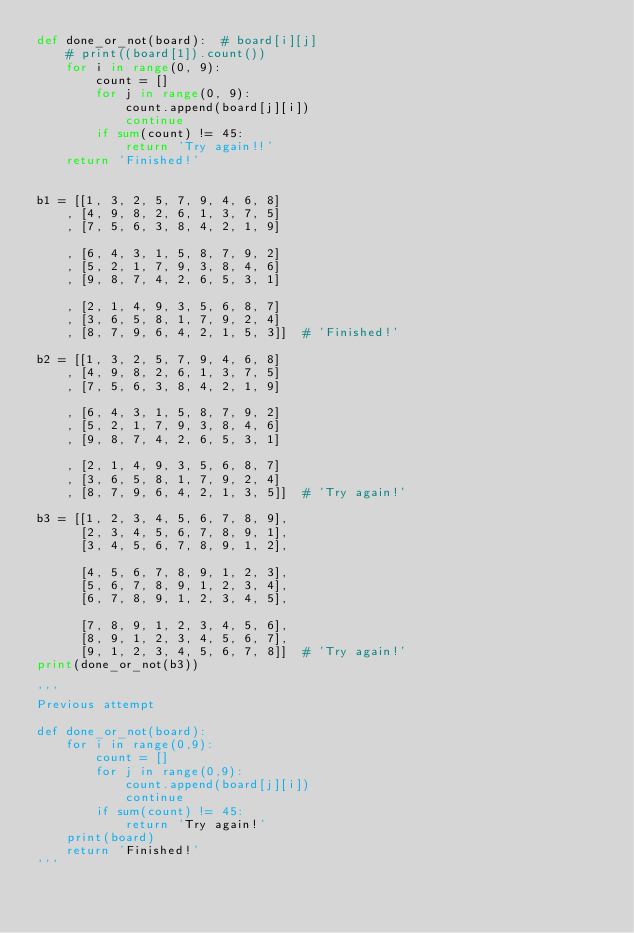Convert code to text. <code><loc_0><loc_0><loc_500><loc_500><_Python_>def done_or_not(board):  # board[i][j]
    # print((board[1]).count())
    for i in range(0, 9):
        count = []
        for j in range(0, 9):
            count.append(board[j][i])
            continue
        if sum(count) != 45:
            return 'Try again!!'
    return 'Finished!'


b1 = [[1, 3, 2, 5, 7, 9, 4, 6, 8]
    , [4, 9, 8, 2, 6, 1, 3, 7, 5]
    , [7, 5, 6, 3, 8, 4, 2, 1, 9]

    , [6, 4, 3, 1, 5, 8, 7, 9, 2]
    , [5, 2, 1, 7, 9, 3, 8, 4, 6]
    , [9, 8, 7, 4, 2, 6, 5, 3, 1]

    , [2, 1, 4, 9, 3, 5, 6, 8, 7]
    , [3, 6, 5, 8, 1, 7, 9, 2, 4]
    , [8, 7, 9, 6, 4, 2, 1, 5, 3]]  # 'Finished!'

b2 = [[1, 3, 2, 5, 7, 9, 4, 6, 8]
    , [4, 9, 8, 2, 6, 1, 3, 7, 5]
    , [7, 5, 6, 3, 8, 4, 2, 1, 9]

    , [6, 4, 3, 1, 5, 8, 7, 9, 2]
    , [5, 2, 1, 7, 9, 3, 8, 4, 6]
    , [9, 8, 7, 4, 2, 6, 5, 3, 1]

    , [2, 1, 4, 9, 3, 5, 6, 8, 7]
    , [3, 6, 5, 8, 1, 7, 9, 2, 4]
    , [8, 7, 9, 6, 4, 2, 1, 3, 5]]  # 'Try again!'

b3 = [[1, 2, 3, 4, 5, 6, 7, 8, 9],
      [2, 3, 4, 5, 6, 7, 8, 9, 1],
      [3, 4, 5, 6, 7, 8, 9, 1, 2],

      [4, 5, 6, 7, 8, 9, 1, 2, 3],
      [5, 6, 7, 8, 9, 1, 2, 3, 4],
      [6, 7, 8, 9, 1, 2, 3, 4, 5],

      [7, 8, 9, 1, 2, 3, 4, 5, 6],
      [8, 9, 1, 2, 3, 4, 5, 6, 7],
      [9, 1, 2, 3, 4, 5, 6, 7, 8]]  # 'Try again!'
print(done_or_not(b3))

'''
Previous attempt 

def done_or_not(board): 
    for i in range(0,9):
        count = []
        for j in range(0,9):
            count.append(board[j][i])
            continue
        if sum(count) != 45:
            return 'Try again!'
    print(board)
    return 'Finished!'
'''
</code> 